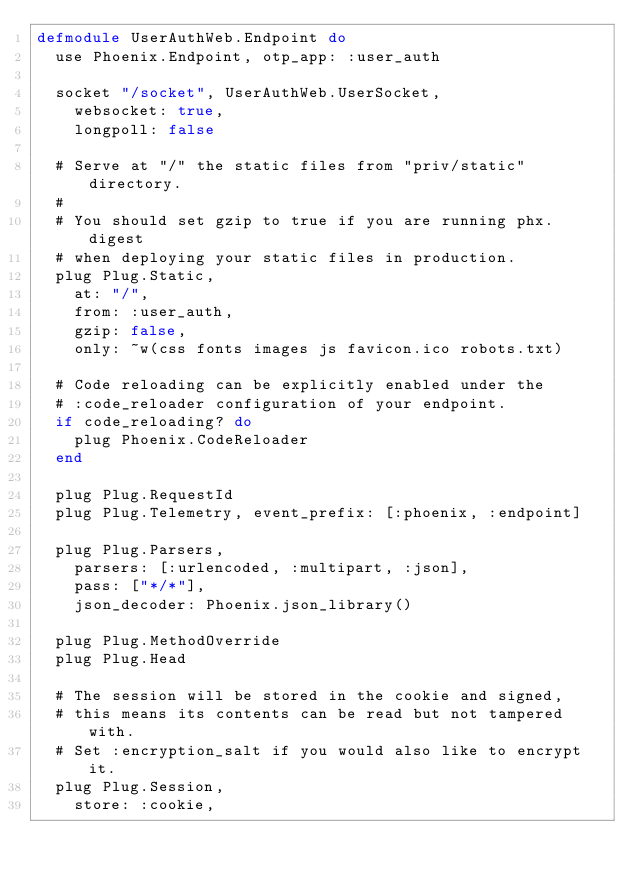Convert code to text. <code><loc_0><loc_0><loc_500><loc_500><_Elixir_>defmodule UserAuthWeb.Endpoint do
  use Phoenix.Endpoint, otp_app: :user_auth

  socket "/socket", UserAuthWeb.UserSocket,
    websocket: true,
    longpoll: false

  # Serve at "/" the static files from "priv/static" directory.
  #
  # You should set gzip to true if you are running phx.digest
  # when deploying your static files in production.
  plug Plug.Static,
    at: "/",
    from: :user_auth,
    gzip: false,
    only: ~w(css fonts images js favicon.ico robots.txt)

  # Code reloading can be explicitly enabled under the
  # :code_reloader configuration of your endpoint.
  if code_reloading? do
    plug Phoenix.CodeReloader
  end

  plug Plug.RequestId
  plug Plug.Telemetry, event_prefix: [:phoenix, :endpoint]

  plug Plug.Parsers,
    parsers: [:urlencoded, :multipart, :json],
    pass: ["*/*"],
    json_decoder: Phoenix.json_library()

  plug Plug.MethodOverride
  plug Plug.Head

  # The session will be stored in the cookie and signed,
  # this means its contents can be read but not tampered with.
  # Set :encryption_salt if you would also like to encrypt it.
  plug Plug.Session,
    store: :cookie,</code> 